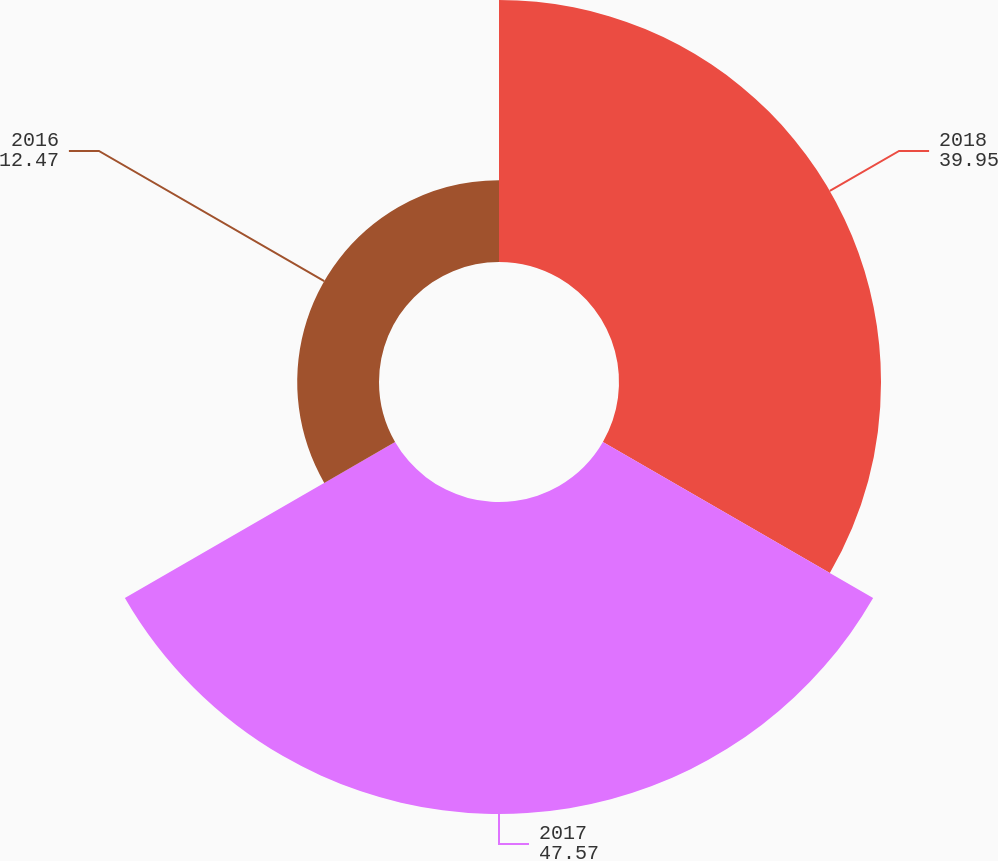<chart> <loc_0><loc_0><loc_500><loc_500><pie_chart><fcel>2018<fcel>2017<fcel>2016<nl><fcel>39.95%<fcel>47.57%<fcel>12.47%<nl></chart> 